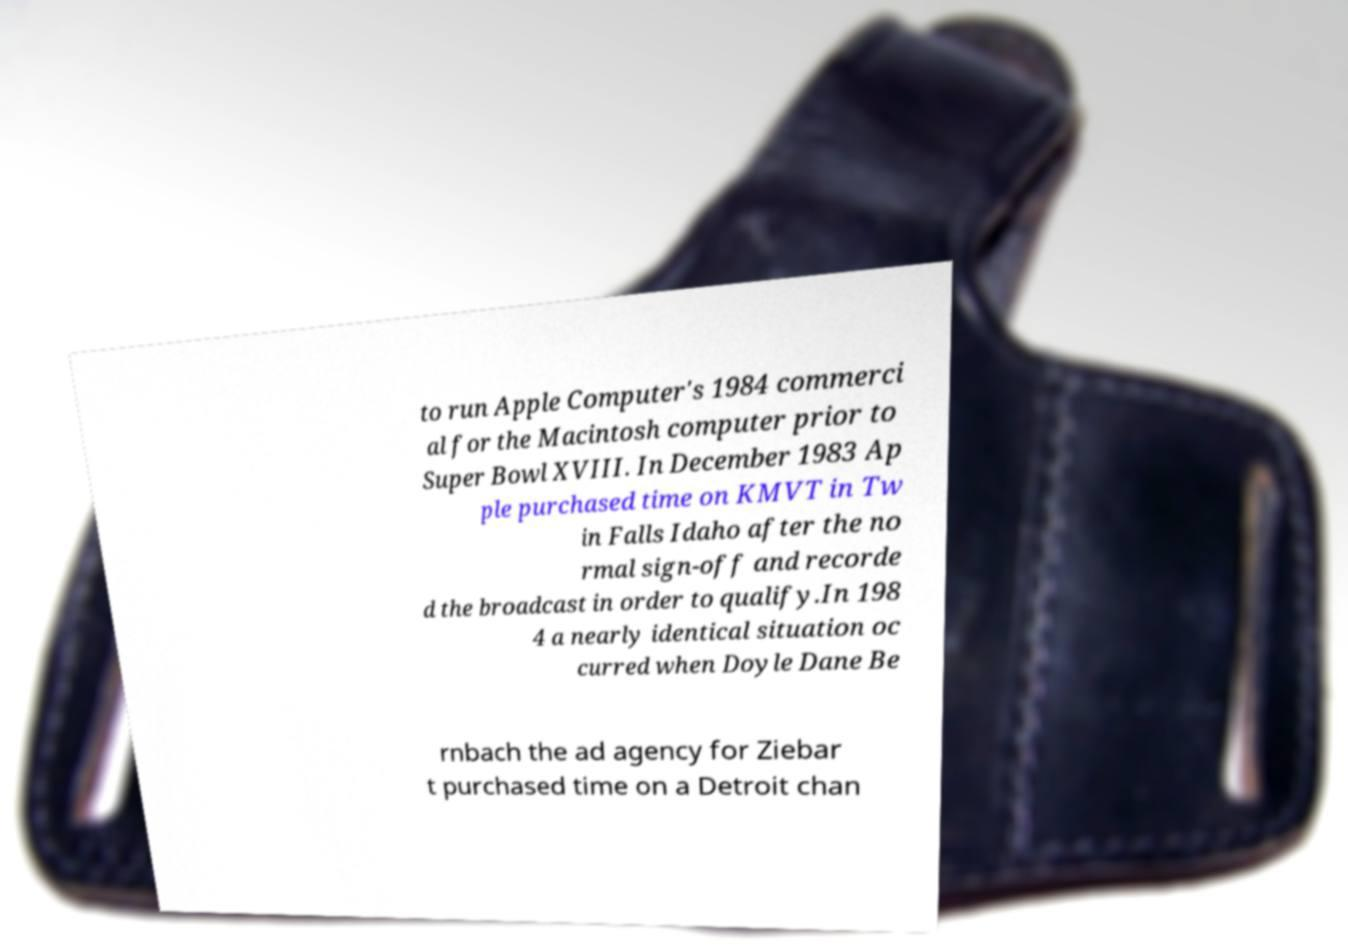Please identify and transcribe the text found in this image. to run Apple Computer's 1984 commerci al for the Macintosh computer prior to Super Bowl XVIII. In December 1983 Ap ple purchased time on KMVT in Tw in Falls Idaho after the no rmal sign-off and recorde d the broadcast in order to qualify.In 198 4 a nearly identical situation oc curred when Doyle Dane Be rnbach the ad agency for Ziebar t purchased time on a Detroit chan 